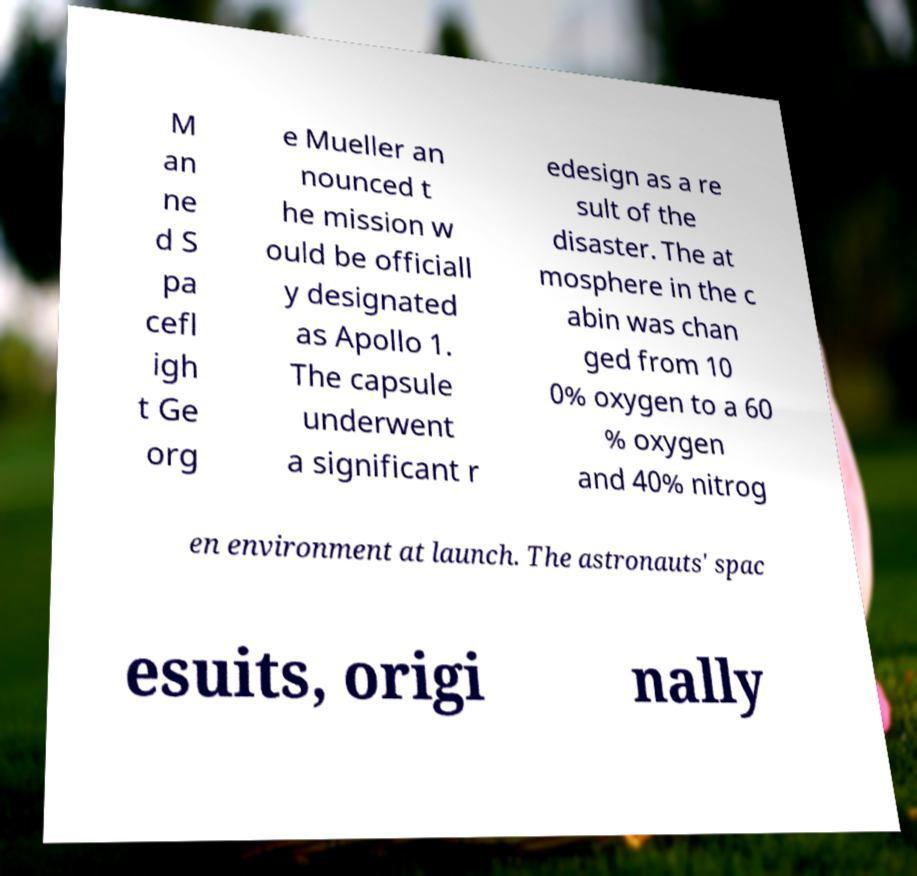There's text embedded in this image that I need extracted. Can you transcribe it verbatim? M an ne d S pa cefl igh t Ge org e Mueller an nounced t he mission w ould be officiall y designated as Apollo 1. The capsule underwent a significant r edesign as a re sult of the disaster. The at mosphere in the c abin was chan ged from 10 0% oxygen to a 60 % oxygen and 40% nitrog en environment at launch. The astronauts' spac esuits, origi nally 